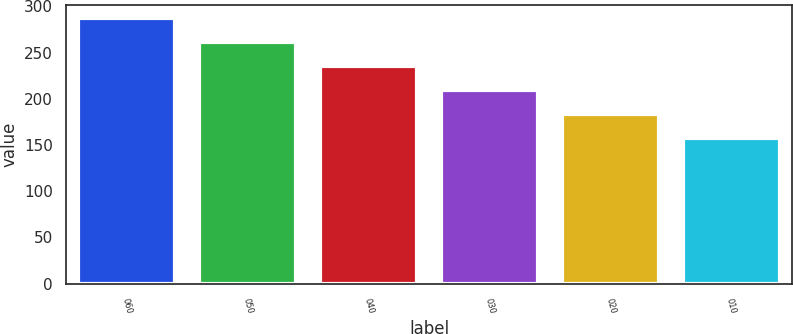Convert chart. <chart><loc_0><loc_0><loc_500><loc_500><bar_chart><fcel>060<fcel>050<fcel>040<fcel>030<fcel>020<fcel>010<nl><fcel>287<fcel>261<fcel>235<fcel>209<fcel>183<fcel>157<nl></chart> 